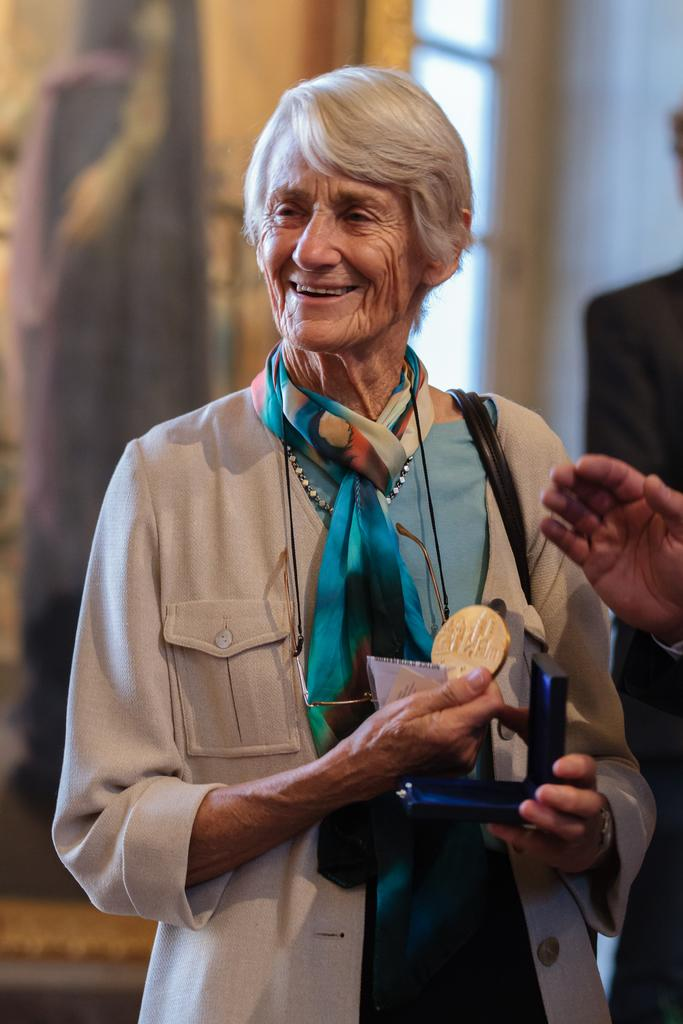Who is present in the image? There is a lady in the image. What is the lady holding in her hands? The lady is holding a box and a coin. What can be seen in the background of the image? The background of the image is blurred. What architectural feature is visible in the image? There is a window and a wall in the image. Whose hand is visible in the image? A person's hand is visible in the image. What type of powder is being used by the society in the image? There is no mention of powder or society in the image; it features a lady holding a box and a coin. 